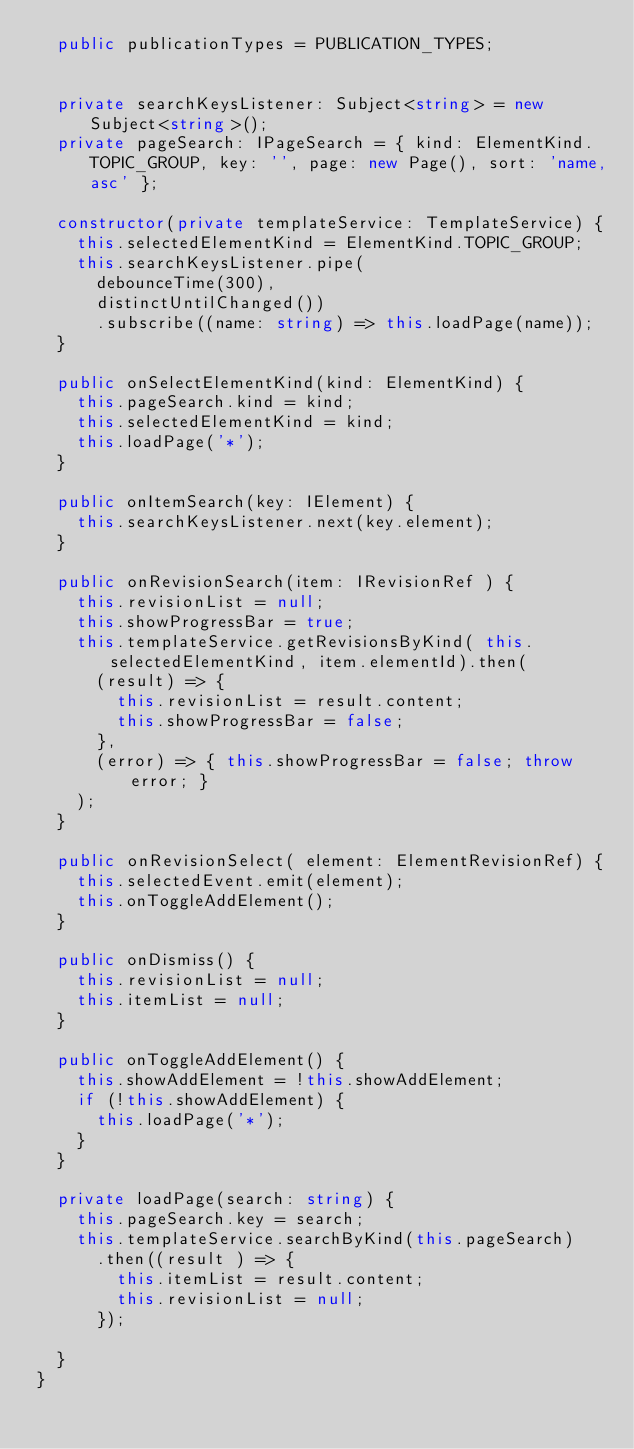Convert code to text. <code><loc_0><loc_0><loc_500><loc_500><_TypeScript_>  public publicationTypes = PUBLICATION_TYPES;


  private searchKeysListener: Subject<string> = new Subject<string>();
  private pageSearch: IPageSearch = { kind: ElementKind.TOPIC_GROUP, key: '', page: new Page(), sort: 'name,asc' };

  constructor(private templateService: TemplateService) {
    this.selectedElementKind = ElementKind.TOPIC_GROUP;
    this.searchKeysListener.pipe(
      debounceTime(300),
      distinctUntilChanged())
      .subscribe((name: string) => this.loadPage(name));
  }

  public onSelectElementKind(kind: ElementKind) {
    this.pageSearch.kind = kind;
    this.selectedElementKind = kind;
    this.loadPage('*');
  }

  public onItemSearch(key: IElement) {
    this.searchKeysListener.next(key.element);
  }

  public onRevisionSearch(item: IRevisionRef ) {
    this.revisionList = null;
    this.showProgressBar = true;
    this.templateService.getRevisionsByKind( this.selectedElementKind, item.elementId).then(
      (result) => {
        this.revisionList = result.content;
        this.showProgressBar = false;
      },
      (error) => { this.showProgressBar = false; throw error; }
    );
  }

  public onRevisionSelect( element: ElementRevisionRef) {
    this.selectedEvent.emit(element);
    this.onToggleAddElement();
  }

  public onDismiss() {
    this.revisionList = null;
    this.itemList = null;
  }

  public onToggleAddElement() {
    this.showAddElement = !this.showAddElement;
    if (!this.showAddElement) {
      this.loadPage('*');
    }
  }

  private loadPage(search: string) {
    this.pageSearch.key = search;
    this.templateService.searchByKind(this.pageSearch)
      .then((result ) => {
        this.itemList = result.content;
        this.revisionList = null;
      });

  }
}


</code> 